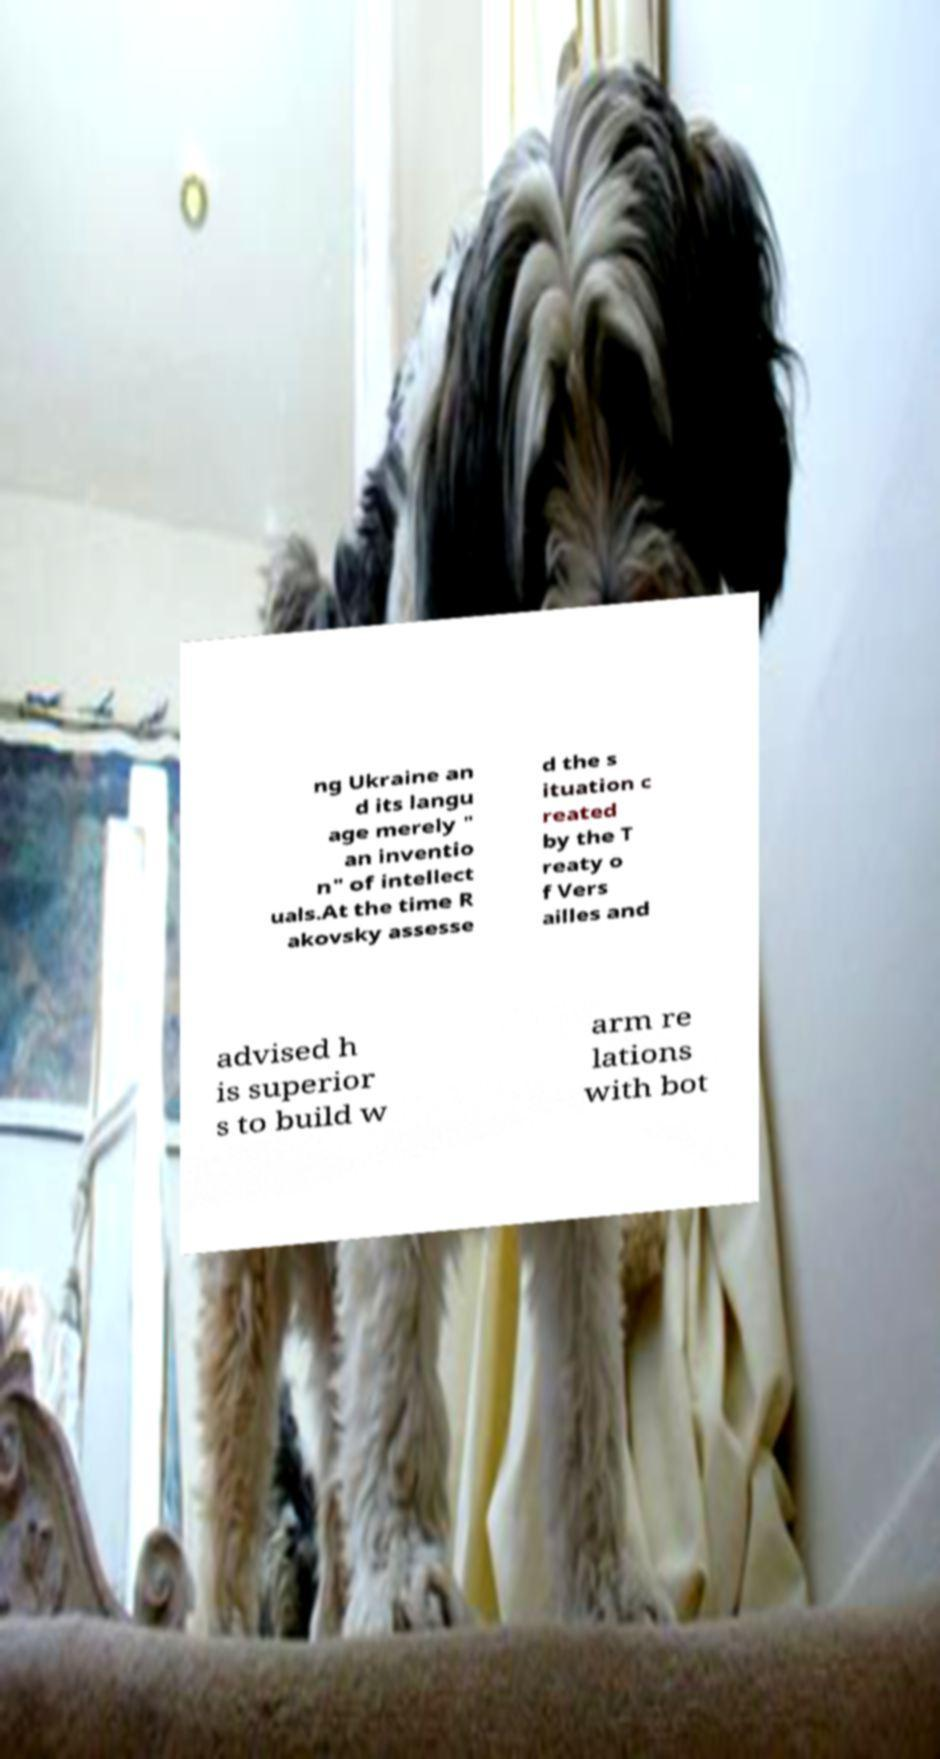Can you accurately transcribe the text from the provided image for me? ng Ukraine an d its langu age merely " an inventio n" of intellect uals.At the time R akovsky assesse d the s ituation c reated by the T reaty o f Vers ailles and advised h is superior s to build w arm re lations with bot 